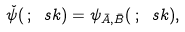<formula> <loc_0><loc_0><loc_500><loc_500>\check { \psi } ( \, ; \ s k ) = \psi _ { \bar { A } , \bar { B } } ( \, ; \ s k ) ,</formula> 